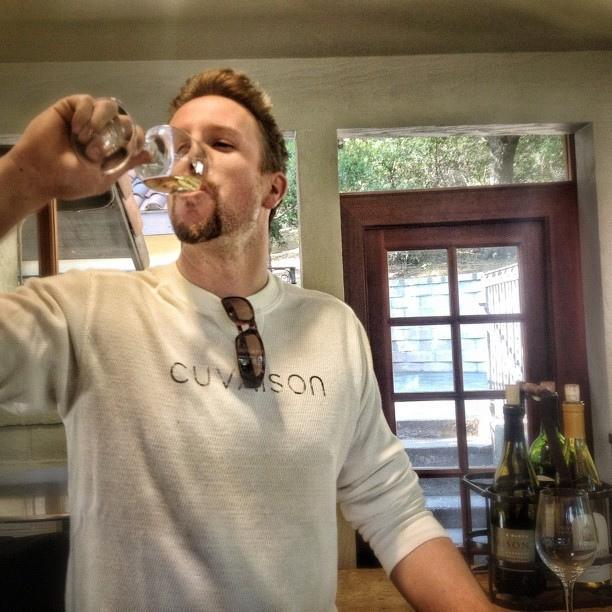Will he need to squint when he walks outside?
Quick response, please. Yes. What is the man drinking?
Keep it brief. Wine. What letters are on the man's shirt in dark blue?
Quick response, please. Cuvaison. Is he wearing a long or short sleeved shirt?
Keep it brief. Long. 